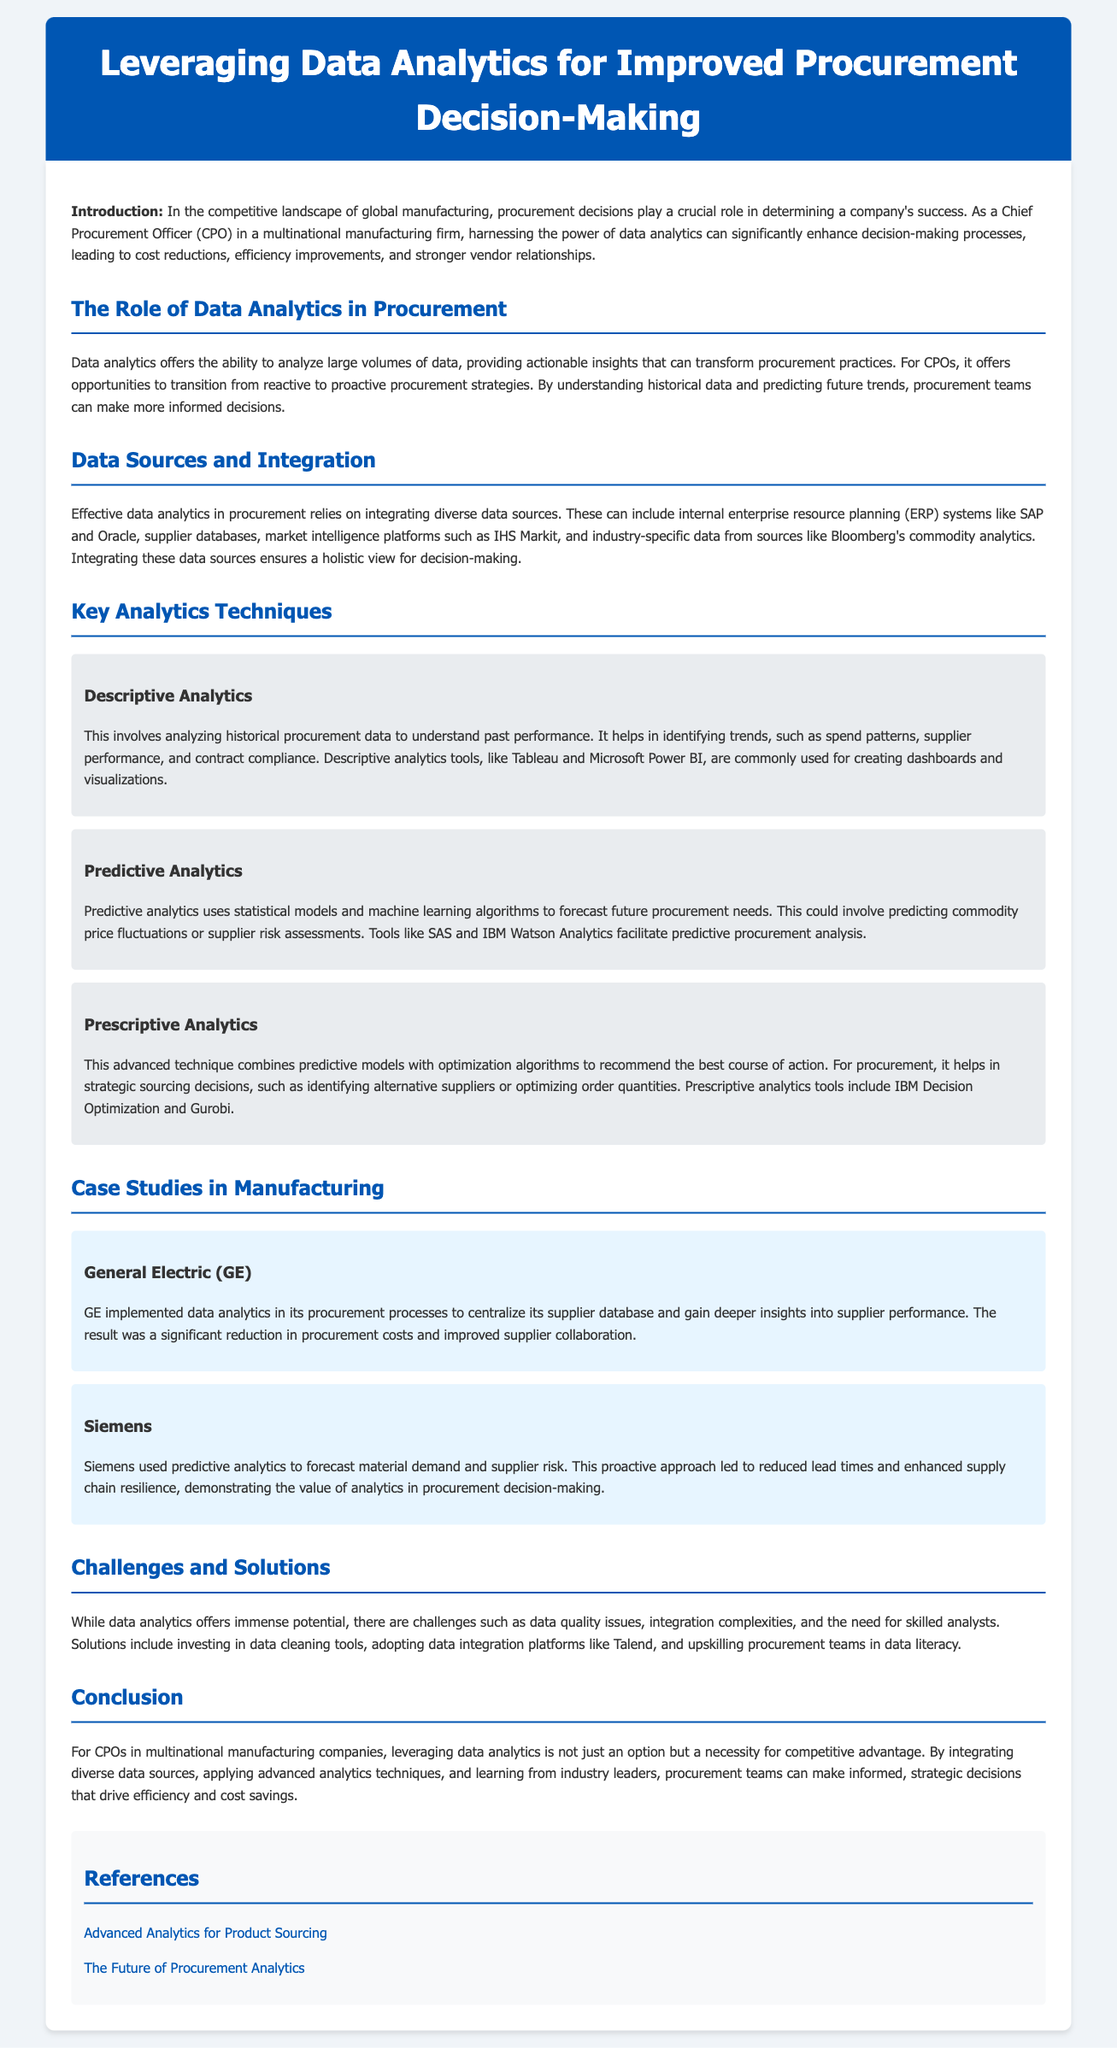what is the title of the whitepaper? The title of the whitepaper is mentioned at the start, which is "Leveraging Data Analytics for Improved Procurement Decision-Making."
Answer: Leveraging Data Analytics for Improved Procurement Decision-Making who are the case studies in the document? The document includes case studies of General Electric and Siemens, highlighting their use of data analytics in procurement.
Answer: General Electric, Siemens what is the main focus of predictive analytics? The main focus of predictive analytics is described as using statistical models and machine learning algorithms to forecast future procurement needs.
Answer: Forecast future procurement needs which analytics tool is mentioned for prescriptive analytics? The document lists IBM Decision Optimization and Gurobi as tools for prescriptive analytics.
Answer: IBM Decision Optimization, Gurobi what are the challenges mentioned in the document regarding data analytics? The document mentions challenges like data quality issues, integration complexities, and the need for skilled analysts.
Answer: Data quality issues, integration complexities, skilled analysts which company improved supplier collaboration through data analytics? The case study of General Electric illustrates that this company improved supplier collaboration by implementing data analytics.
Answer: General Electric what is one solution to data quality issues mentioned? The document suggests investing in data cleaning tools as a solution to data quality problems.
Answer: Investing in data cleaning tools what are the benefits of leveraging data analytics in procurement? The benefits are described as cost reductions, efficiency improvements, and stronger vendor relationships.
Answer: Cost reductions, efficiency improvements, stronger vendor relationships 